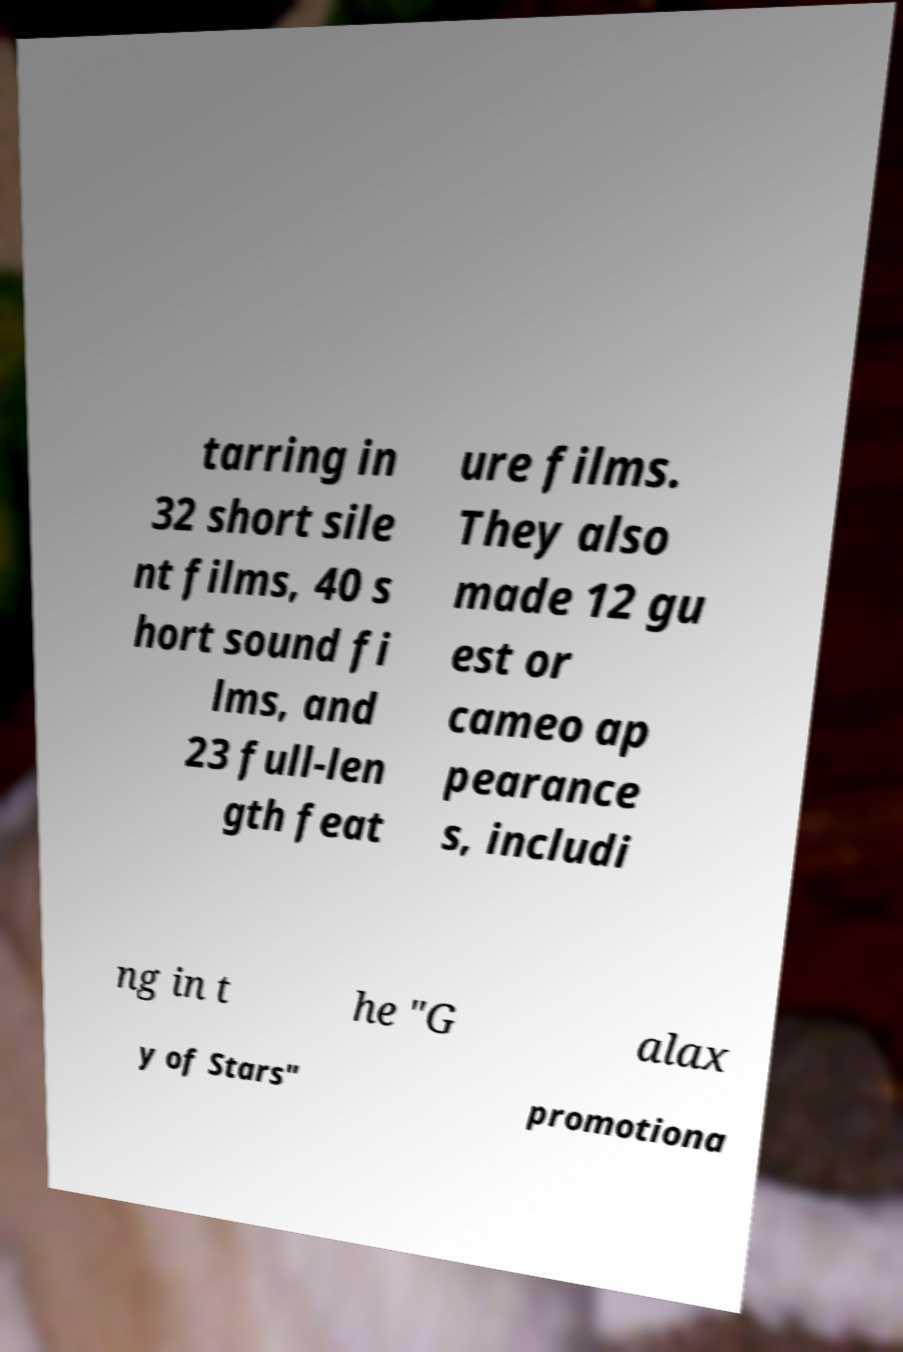Can you accurately transcribe the text from the provided image for me? tarring in 32 short sile nt films, 40 s hort sound fi lms, and 23 full-len gth feat ure films. They also made 12 gu est or cameo ap pearance s, includi ng in t he "G alax y of Stars" promotiona 